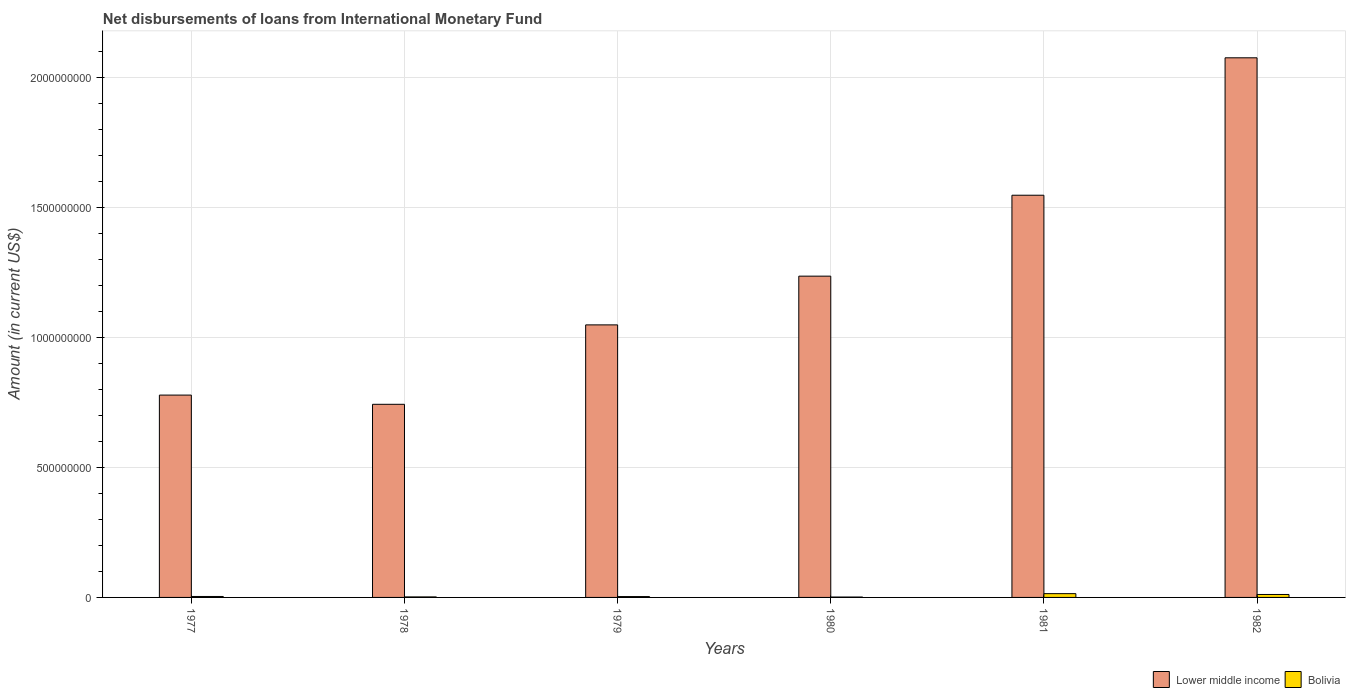How many different coloured bars are there?
Make the answer very short. 2. Are the number of bars on each tick of the X-axis equal?
Provide a succinct answer. Yes. How many bars are there on the 2nd tick from the left?
Your answer should be very brief. 2. What is the amount of loans disbursed in Lower middle income in 1978?
Offer a terse response. 7.43e+08. Across all years, what is the maximum amount of loans disbursed in Lower middle income?
Ensure brevity in your answer.  2.07e+09. Across all years, what is the minimum amount of loans disbursed in Lower middle income?
Your response must be concise. 7.43e+08. In which year was the amount of loans disbursed in Lower middle income minimum?
Offer a very short reply. 1978. What is the total amount of loans disbursed in Lower middle income in the graph?
Your answer should be very brief. 7.43e+09. What is the difference between the amount of loans disbursed in Bolivia in 1977 and that in 1981?
Your answer should be very brief. -1.08e+07. What is the difference between the amount of loans disbursed in Bolivia in 1981 and the amount of loans disbursed in Lower middle income in 1982?
Provide a short and direct response. -2.06e+09. What is the average amount of loans disbursed in Bolivia per year?
Your answer should be very brief. 6.04e+06. In the year 1979, what is the difference between the amount of loans disbursed in Bolivia and amount of loans disbursed in Lower middle income?
Your answer should be very brief. -1.04e+09. What is the ratio of the amount of loans disbursed in Lower middle income in 1978 to that in 1979?
Make the answer very short. 0.71. What is the difference between the highest and the second highest amount of loans disbursed in Lower middle income?
Make the answer very short. 5.28e+08. What is the difference between the highest and the lowest amount of loans disbursed in Lower middle income?
Keep it short and to the point. 1.33e+09. In how many years, is the amount of loans disbursed in Lower middle income greater than the average amount of loans disbursed in Lower middle income taken over all years?
Provide a succinct answer. 2. Is the sum of the amount of loans disbursed in Lower middle income in 1977 and 1982 greater than the maximum amount of loans disbursed in Bolivia across all years?
Provide a succinct answer. Yes. What does the 2nd bar from the left in 1981 represents?
Your answer should be very brief. Bolivia. Are all the bars in the graph horizontal?
Provide a short and direct response. No. How many years are there in the graph?
Offer a terse response. 6. Are the values on the major ticks of Y-axis written in scientific E-notation?
Your answer should be compact. No. How are the legend labels stacked?
Provide a short and direct response. Horizontal. What is the title of the graph?
Ensure brevity in your answer.  Net disbursements of loans from International Monetary Fund. Does "High income: nonOECD" appear as one of the legend labels in the graph?
Offer a terse response. No. What is the label or title of the X-axis?
Ensure brevity in your answer.  Years. What is the Amount (in current US$) of Lower middle income in 1977?
Your answer should be very brief. 7.78e+08. What is the Amount (in current US$) in Bolivia in 1977?
Make the answer very short. 3.68e+06. What is the Amount (in current US$) of Lower middle income in 1978?
Provide a succinct answer. 7.43e+08. What is the Amount (in current US$) in Bolivia in 1978?
Your answer should be compact. 1.98e+06. What is the Amount (in current US$) of Lower middle income in 1979?
Keep it short and to the point. 1.05e+09. What is the Amount (in current US$) in Bolivia in 1979?
Your answer should be compact. 3.26e+06. What is the Amount (in current US$) in Lower middle income in 1980?
Give a very brief answer. 1.24e+09. What is the Amount (in current US$) of Bolivia in 1980?
Offer a terse response. 1.47e+06. What is the Amount (in current US$) of Lower middle income in 1981?
Make the answer very short. 1.55e+09. What is the Amount (in current US$) of Bolivia in 1981?
Your answer should be very brief. 1.45e+07. What is the Amount (in current US$) in Lower middle income in 1982?
Ensure brevity in your answer.  2.07e+09. What is the Amount (in current US$) of Bolivia in 1982?
Make the answer very short. 1.14e+07. Across all years, what is the maximum Amount (in current US$) in Lower middle income?
Your response must be concise. 2.07e+09. Across all years, what is the maximum Amount (in current US$) of Bolivia?
Offer a terse response. 1.45e+07. Across all years, what is the minimum Amount (in current US$) in Lower middle income?
Your answer should be very brief. 7.43e+08. Across all years, what is the minimum Amount (in current US$) in Bolivia?
Provide a succinct answer. 1.47e+06. What is the total Amount (in current US$) of Lower middle income in the graph?
Give a very brief answer. 7.43e+09. What is the total Amount (in current US$) in Bolivia in the graph?
Offer a terse response. 3.63e+07. What is the difference between the Amount (in current US$) of Lower middle income in 1977 and that in 1978?
Make the answer very short. 3.54e+07. What is the difference between the Amount (in current US$) of Bolivia in 1977 and that in 1978?
Offer a very short reply. 1.70e+06. What is the difference between the Amount (in current US$) in Lower middle income in 1977 and that in 1979?
Provide a short and direct response. -2.70e+08. What is the difference between the Amount (in current US$) in Bolivia in 1977 and that in 1979?
Provide a succinct answer. 4.13e+05. What is the difference between the Amount (in current US$) of Lower middle income in 1977 and that in 1980?
Provide a short and direct response. -4.57e+08. What is the difference between the Amount (in current US$) in Bolivia in 1977 and that in 1980?
Your answer should be compact. 2.21e+06. What is the difference between the Amount (in current US$) of Lower middle income in 1977 and that in 1981?
Offer a very short reply. -7.69e+08. What is the difference between the Amount (in current US$) in Bolivia in 1977 and that in 1981?
Give a very brief answer. -1.08e+07. What is the difference between the Amount (in current US$) in Lower middle income in 1977 and that in 1982?
Your answer should be compact. -1.30e+09. What is the difference between the Amount (in current US$) of Bolivia in 1977 and that in 1982?
Offer a very short reply. -7.68e+06. What is the difference between the Amount (in current US$) in Lower middle income in 1978 and that in 1979?
Provide a succinct answer. -3.05e+08. What is the difference between the Amount (in current US$) in Bolivia in 1978 and that in 1979?
Your response must be concise. -1.28e+06. What is the difference between the Amount (in current US$) in Lower middle income in 1978 and that in 1980?
Your answer should be compact. -4.93e+08. What is the difference between the Amount (in current US$) in Bolivia in 1978 and that in 1980?
Provide a short and direct response. 5.10e+05. What is the difference between the Amount (in current US$) of Lower middle income in 1978 and that in 1981?
Provide a short and direct response. -8.04e+08. What is the difference between the Amount (in current US$) in Bolivia in 1978 and that in 1981?
Make the answer very short. -1.25e+07. What is the difference between the Amount (in current US$) in Lower middle income in 1978 and that in 1982?
Your response must be concise. -1.33e+09. What is the difference between the Amount (in current US$) in Bolivia in 1978 and that in 1982?
Offer a very short reply. -9.38e+06. What is the difference between the Amount (in current US$) in Lower middle income in 1979 and that in 1980?
Provide a succinct answer. -1.87e+08. What is the difference between the Amount (in current US$) of Bolivia in 1979 and that in 1980?
Offer a very short reply. 1.79e+06. What is the difference between the Amount (in current US$) of Lower middle income in 1979 and that in 1981?
Give a very brief answer. -4.99e+08. What is the difference between the Amount (in current US$) in Bolivia in 1979 and that in 1981?
Provide a short and direct response. -1.13e+07. What is the difference between the Amount (in current US$) in Lower middle income in 1979 and that in 1982?
Offer a very short reply. -1.03e+09. What is the difference between the Amount (in current US$) of Bolivia in 1979 and that in 1982?
Your response must be concise. -8.09e+06. What is the difference between the Amount (in current US$) of Lower middle income in 1980 and that in 1981?
Give a very brief answer. -3.11e+08. What is the difference between the Amount (in current US$) in Bolivia in 1980 and that in 1981?
Your response must be concise. -1.30e+07. What is the difference between the Amount (in current US$) of Lower middle income in 1980 and that in 1982?
Provide a short and direct response. -8.40e+08. What is the difference between the Amount (in current US$) of Bolivia in 1980 and that in 1982?
Ensure brevity in your answer.  -9.89e+06. What is the difference between the Amount (in current US$) in Lower middle income in 1981 and that in 1982?
Your answer should be very brief. -5.28e+08. What is the difference between the Amount (in current US$) in Bolivia in 1981 and that in 1982?
Ensure brevity in your answer.  3.16e+06. What is the difference between the Amount (in current US$) in Lower middle income in 1977 and the Amount (in current US$) in Bolivia in 1978?
Keep it short and to the point. 7.76e+08. What is the difference between the Amount (in current US$) of Lower middle income in 1977 and the Amount (in current US$) of Bolivia in 1979?
Your answer should be compact. 7.75e+08. What is the difference between the Amount (in current US$) in Lower middle income in 1977 and the Amount (in current US$) in Bolivia in 1980?
Ensure brevity in your answer.  7.77e+08. What is the difference between the Amount (in current US$) of Lower middle income in 1977 and the Amount (in current US$) of Bolivia in 1981?
Your answer should be compact. 7.64e+08. What is the difference between the Amount (in current US$) of Lower middle income in 1977 and the Amount (in current US$) of Bolivia in 1982?
Keep it short and to the point. 7.67e+08. What is the difference between the Amount (in current US$) of Lower middle income in 1978 and the Amount (in current US$) of Bolivia in 1979?
Keep it short and to the point. 7.39e+08. What is the difference between the Amount (in current US$) in Lower middle income in 1978 and the Amount (in current US$) in Bolivia in 1980?
Your answer should be very brief. 7.41e+08. What is the difference between the Amount (in current US$) in Lower middle income in 1978 and the Amount (in current US$) in Bolivia in 1981?
Ensure brevity in your answer.  7.28e+08. What is the difference between the Amount (in current US$) of Lower middle income in 1978 and the Amount (in current US$) of Bolivia in 1982?
Offer a very short reply. 7.31e+08. What is the difference between the Amount (in current US$) in Lower middle income in 1979 and the Amount (in current US$) in Bolivia in 1980?
Offer a very short reply. 1.05e+09. What is the difference between the Amount (in current US$) in Lower middle income in 1979 and the Amount (in current US$) in Bolivia in 1981?
Make the answer very short. 1.03e+09. What is the difference between the Amount (in current US$) in Lower middle income in 1979 and the Amount (in current US$) in Bolivia in 1982?
Ensure brevity in your answer.  1.04e+09. What is the difference between the Amount (in current US$) in Lower middle income in 1980 and the Amount (in current US$) in Bolivia in 1981?
Provide a succinct answer. 1.22e+09. What is the difference between the Amount (in current US$) of Lower middle income in 1980 and the Amount (in current US$) of Bolivia in 1982?
Provide a short and direct response. 1.22e+09. What is the difference between the Amount (in current US$) in Lower middle income in 1981 and the Amount (in current US$) in Bolivia in 1982?
Offer a very short reply. 1.54e+09. What is the average Amount (in current US$) in Lower middle income per year?
Your answer should be compact. 1.24e+09. What is the average Amount (in current US$) of Bolivia per year?
Provide a succinct answer. 6.04e+06. In the year 1977, what is the difference between the Amount (in current US$) of Lower middle income and Amount (in current US$) of Bolivia?
Offer a terse response. 7.74e+08. In the year 1978, what is the difference between the Amount (in current US$) in Lower middle income and Amount (in current US$) in Bolivia?
Your answer should be compact. 7.41e+08. In the year 1979, what is the difference between the Amount (in current US$) in Lower middle income and Amount (in current US$) in Bolivia?
Offer a very short reply. 1.04e+09. In the year 1980, what is the difference between the Amount (in current US$) in Lower middle income and Amount (in current US$) in Bolivia?
Ensure brevity in your answer.  1.23e+09. In the year 1981, what is the difference between the Amount (in current US$) in Lower middle income and Amount (in current US$) in Bolivia?
Provide a succinct answer. 1.53e+09. In the year 1982, what is the difference between the Amount (in current US$) of Lower middle income and Amount (in current US$) of Bolivia?
Ensure brevity in your answer.  2.06e+09. What is the ratio of the Amount (in current US$) in Lower middle income in 1977 to that in 1978?
Your response must be concise. 1.05. What is the ratio of the Amount (in current US$) of Bolivia in 1977 to that in 1978?
Offer a terse response. 1.86. What is the ratio of the Amount (in current US$) in Lower middle income in 1977 to that in 1979?
Make the answer very short. 0.74. What is the ratio of the Amount (in current US$) in Bolivia in 1977 to that in 1979?
Your answer should be compact. 1.13. What is the ratio of the Amount (in current US$) of Lower middle income in 1977 to that in 1980?
Your answer should be very brief. 0.63. What is the ratio of the Amount (in current US$) in Bolivia in 1977 to that in 1980?
Provide a succinct answer. 2.5. What is the ratio of the Amount (in current US$) of Lower middle income in 1977 to that in 1981?
Provide a succinct answer. 0.5. What is the ratio of the Amount (in current US$) in Bolivia in 1977 to that in 1981?
Your answer should be compact. 0.25. What is the ratio of the Amount (in current US$) of Lower middle income in 1977 to that in 1982?
Your answer should be very brief. 0.38. What is the ratio of the Amount (in current US$) in Bolivia in 1977 to that in 1982?
Make the answer very short. 0.32. What is the ratio of the Amount (in current US$) in Lower middle income in 1978 to that in 1979?
Provide a short and direct response. 0.71. What is the ratio of the Amount (in current US$) in Bolivia in 1978 to that in 1979?
Ensure brevity in your answer.  0.61. What is the ratio of the Amount (in current US$) in Lower middle income in 1978 to that in 1980?
Your answer should be very brief. 0.6. What is the ratio of the Amount (in current US$) in Bolivia in 1978 to that in 1980?
Your response must be concise. 1.35. What is the ratio of the Amount (in current US$) of Lower middle income in 1978 to that in 1981?
Offer a very short reply. 0.48. What is the ratio of the Amount (in current US$) of Bolivia in 1978 to that in 1981?
Offer a very short reply. 0.14. What is the ratio of the Amount (in current US$) of Lower middle income in 1978 to that in 1982?
Ensure brevity in your answer.  0.36. What is the ratio of the Amount (in current US$) of Bolivia in 1978 to that in 1982?
Keep it short and to the point. 0.17. What is the ratio of the Amount (in current US$) of Lower middle income in 1979 to that in 1980?
Make the answer very short. 0.85. What is the ratio of the Amount (in current US$) of Bolivia in 1979 to that in 1980?
Provide a succinct answer. 2.22. What is the ratio of the Amount (in current US$) in Lower middle income in 1979 to that in 1981?
Provide a short and direct response. 0.68. What is the ratio of the Amount (in current US$) in Bolivia in 1979 to that in 1981?
Your answer should be compact. 0.22. What is the ratio of the Amount (in current US$) in Lower middle income in 1979 to that in 1982?
Ensure brevity in your answer.  0.51. What is the ratio of the Amount (in current US$) of Bolivia in 1979 to that in 1982?
Your response must be concise. 0.29. What is the ratio of the Amount (in current US$) in Lower middle income in 1980 to that in 1981?
Make the answer very short. 0.8. What is the ratio of the Amount (in current US$) in Bolivia in 1980 to that in 1981?
Ensure brevity in your answer.  0.1. What is the ratio of the Amount (in current US$) of Lower middle income in 1980 to that in 1982?
Your answer should be very brief. 0.6. What is the ratio of the Amount (in current US$) in Bolivia in 1980 to that in 1982?
Provide a succinct answer. 0.13. What is the ratio of the Amount (in current US$) in Lower middle income in 1981 to that in 1982?
Ensure brevity in your answer.  0.75. What is the ratio of the Amount (in current US$) in Bolivia in 1981 to that in 1982?
Ensure brevity in your answer.  1.28. What is the difference between the highest and the second highest Amount (in current US$) in Lower middle income?
Offer a very short reply. 5.28e+08. What is the difference between the highest and the second highest Amount (in current US$) of Bolivia?
Your response must be concise. 3.16e+06. What is the difference between the highest and the lowest Amount (in current US$) in Lower middle income?
Give a very brief answer. 1.33e+09. What is the difference between the highest and the lowest Amount (in current US$) in Bolivia?
Your answer should be compact. 1.30e+07. 